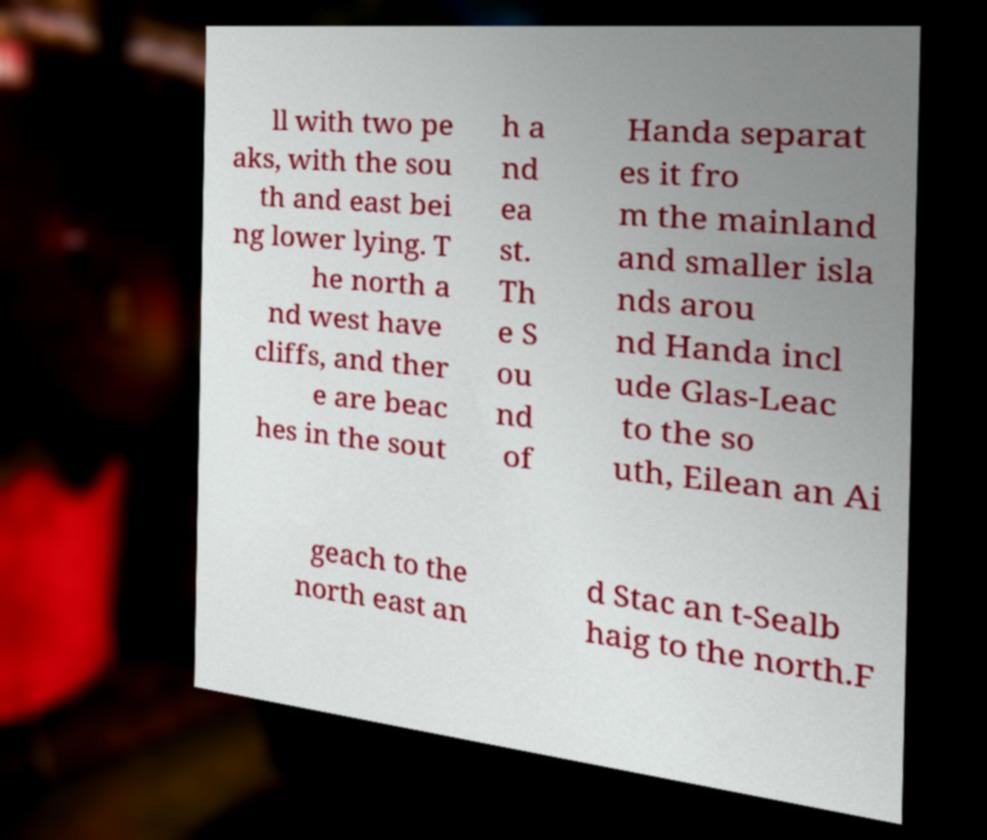Could you extract and type out the text from this image? ll with two pe aks, with the sou th and east bei ng lower lying. T he north a nd west have cliffs, and ther e are beac hes in the sout h a nd ea st. Th e S ou nd of Handa separat es it fro m the mainland and smaller isla nds arou nd Handa incl ude Glas-Leac to the so uth, Eilean an Ai geach to the north east an d Stac an t-Sealb haig to the north.F 